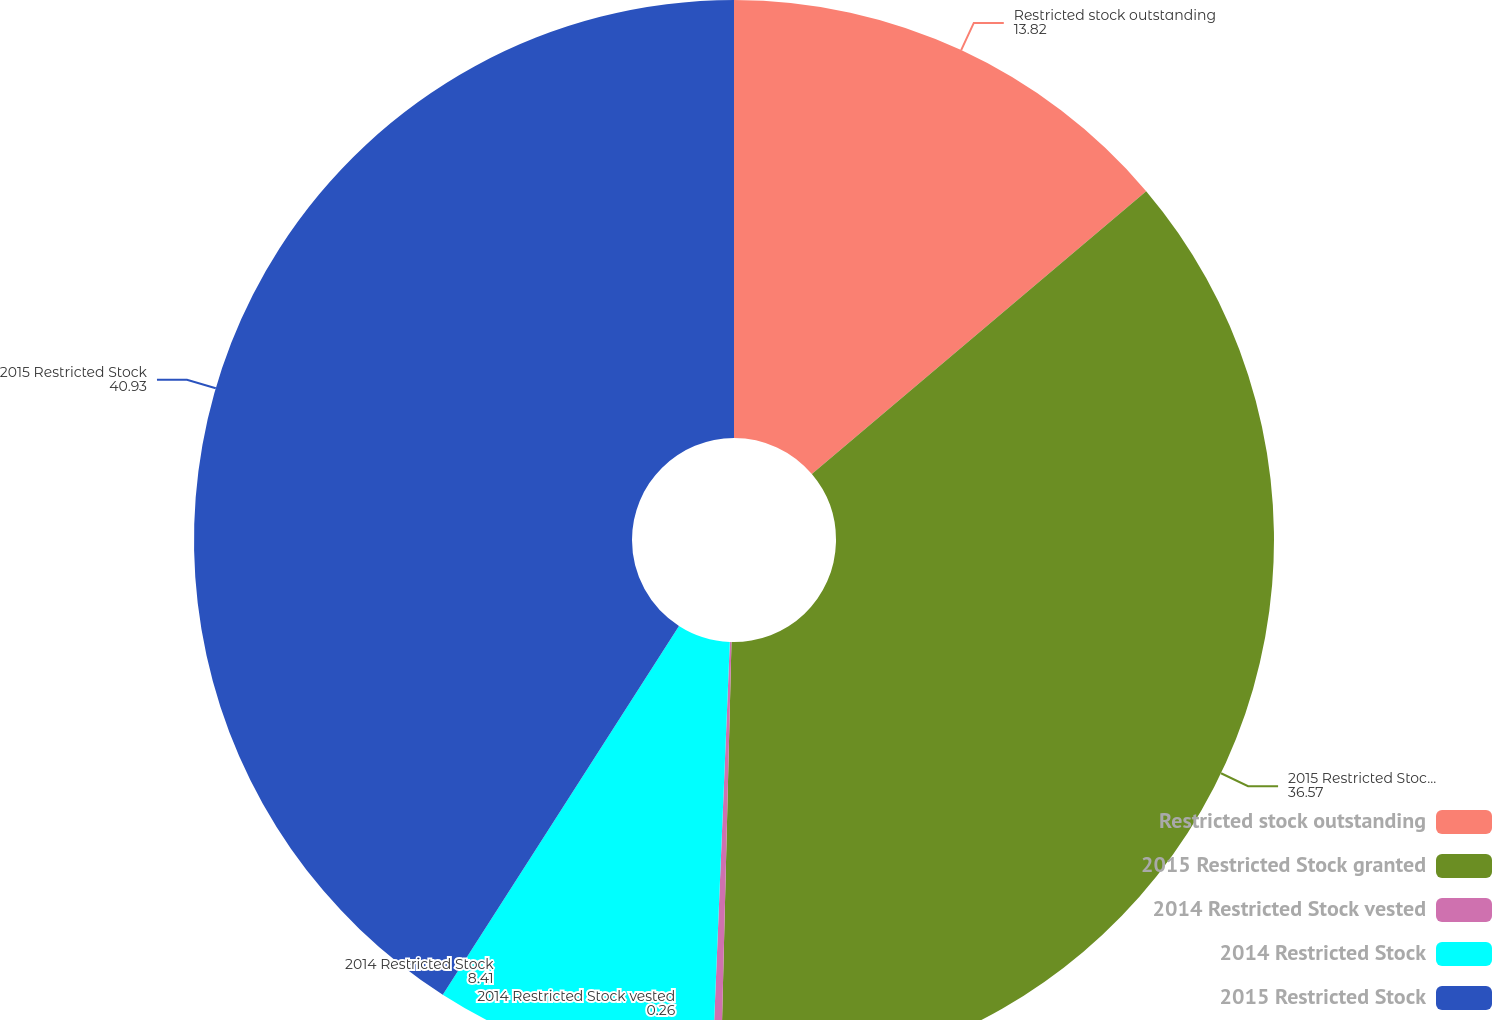Convert chart. <chart><loc_0><loc_0><loc_500><loc_500><pie_chart><fcel>Restricted stock outstanding<fcel>2015 Restricted Stock granted<fcel>2014 Restricted Stock vested<fcel>2014 Restricted Stock<fcel>2015 Restricted Stock<nl><fcel>13.82%<fcel>36.57%<fcel>0.26%<fcel>8.41%<fcel>40.93%<nl></chart> 